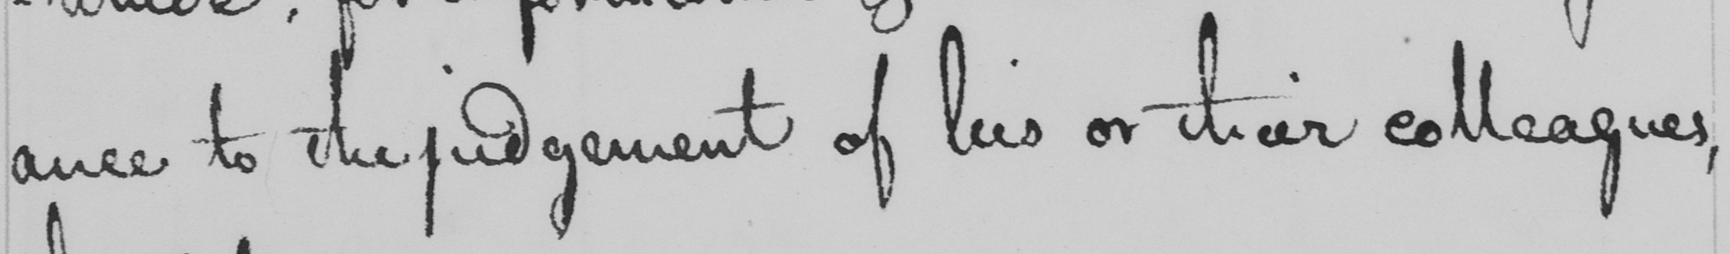What does this handwritten line say? ance to the judgement of his or their colleagues , 